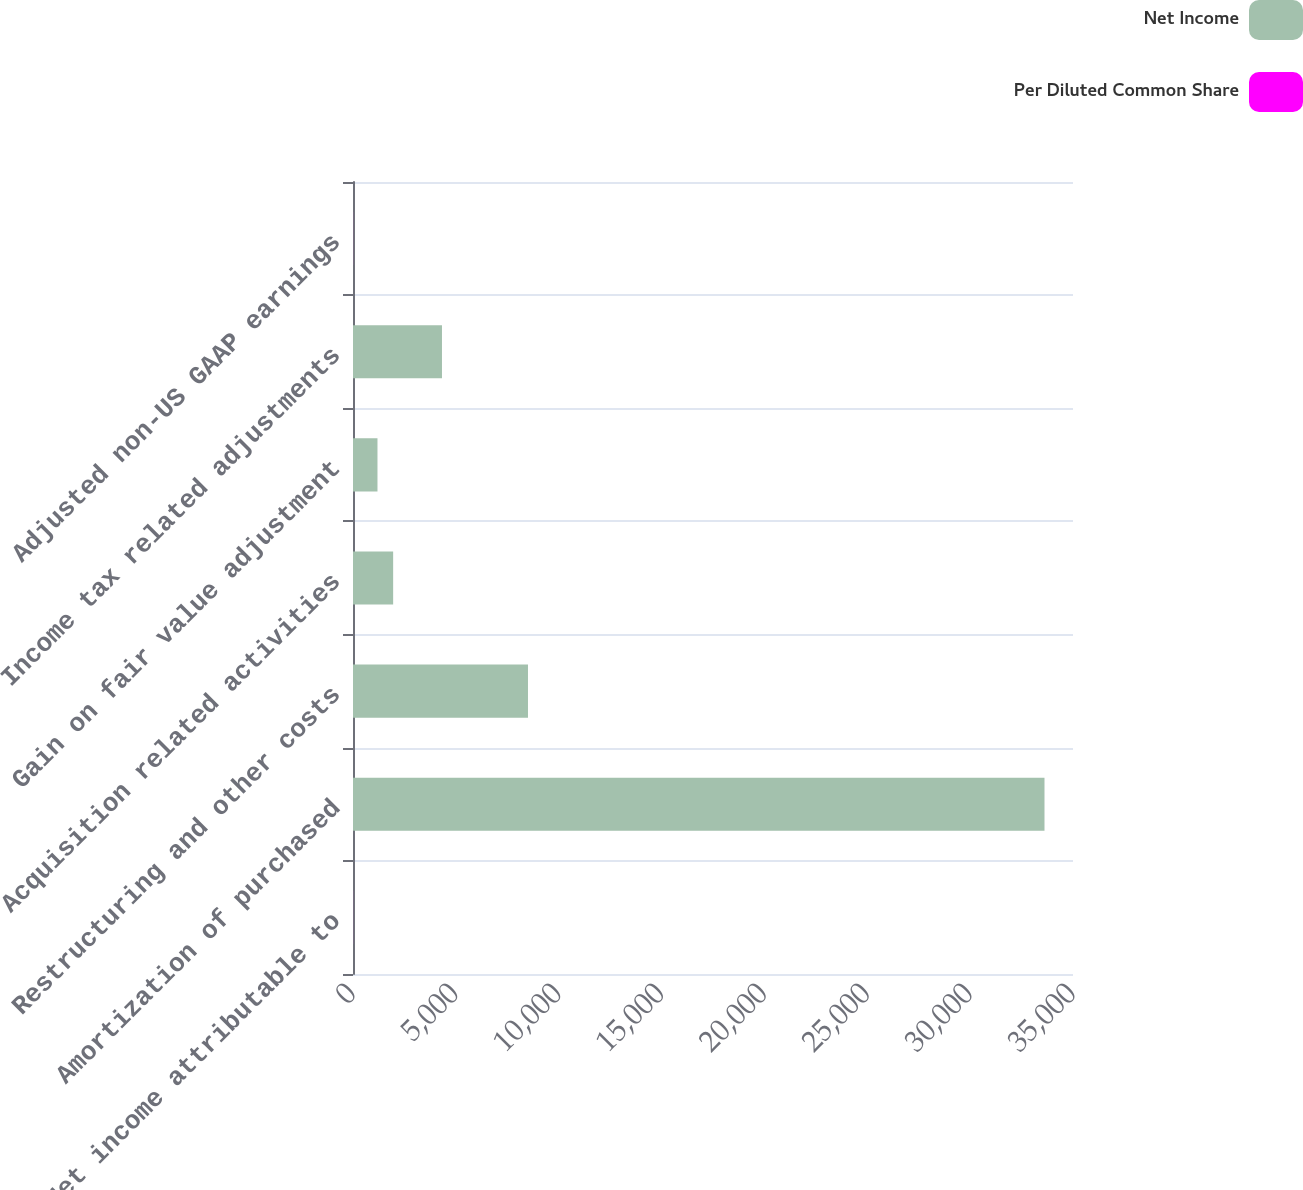<chart> <loc_0><loc_0><loc_500><loc_500><stacked_bar_chart><ecel><fcel>Net income attributable to<fcel>Amortization of purchased<fcel>Restructuring and other costs<fcel>Acquisition related activities<fcel>Gain on fair value adjustment<fcel>Income tax related adjustments<fcel>Adjusted non-US GAAP earnings<nl><fcel>Net Income<fcel>2.37<fcel>33614<fcel>8506<fcel>1952<fcel>1190<fcel>4325<fcel>2.37<nl><fcel>Per Diluted Common Share<fcel>2.24<fcel>0.23<fcel>0.06<fcel>0.01<fcel>0.01<fcel>0.03<fcel>2.5<nl></chart> 